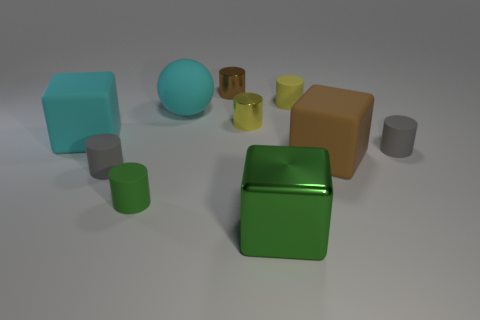Is the number of gray cylinders that are in front of the tiny green cylinder less than the number of small green metal balls?
Offer a very short reply. No. Are there any cyan matte blocks that have the same size as the cyan sphere?
Give a very brief answer. Yes. There is a big ball that is made of the same material as the cyan block; what color is it?
Ensure brevity in your answer.  Cyan. What number of yellow cylinders are behind the large object behind the large cyan matte cube?
Provide a short and direct response. 1. There is a cube that is on the left side of the brown matte object and right of the green cylinder; what material is it made of?
Give a very brief answer. Metal. There is a gray matte thing left of the large brown matte cube; is it the same shape as the green rubber object?
Your answer should be very brief. Yes. Is the number of brown rubber blocks less than the number of large purple spheres?
Offer a very short reply. No. How many things have the same color as the big rubber sphere?
Provide a short and direct response. 1. Does the large ball have the same color as the large matte block that is left of the brown cylinder?
Provide a succinct answer. Yes. Is the number of red rubber blocks greater than the number of metallic cylinders?
Ensure brevity in your answer.  No. 